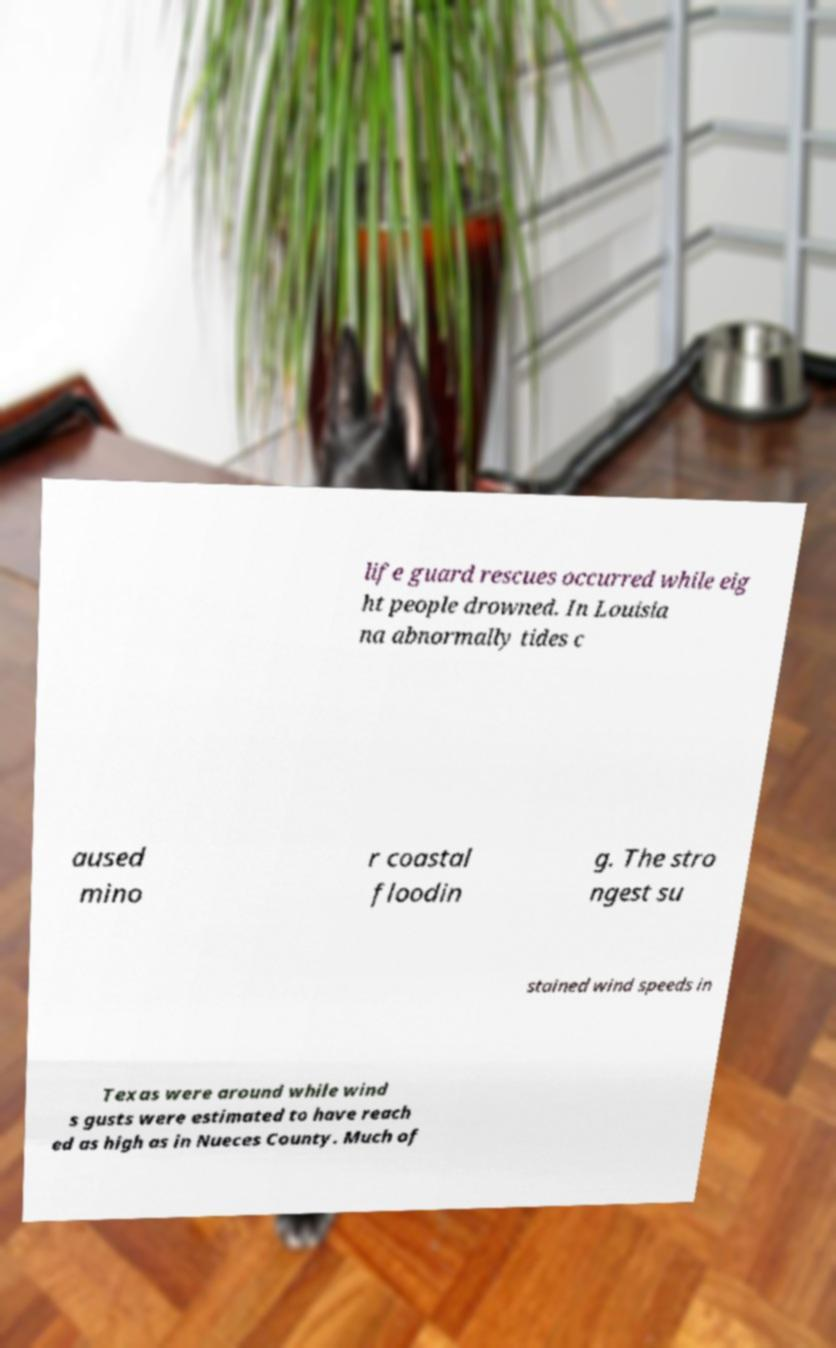What messages or text are displayed in this image? I need them in a readable, typed format. life guard rescues occurred while eig ht people drowned. In Louisia na abnormally tides c aused mino r coastal floodin g. The stro ngest su stained wind speeds in Texas were around while wind s gusts were estimated to have reach ed as high as in Nueces County. Much of 